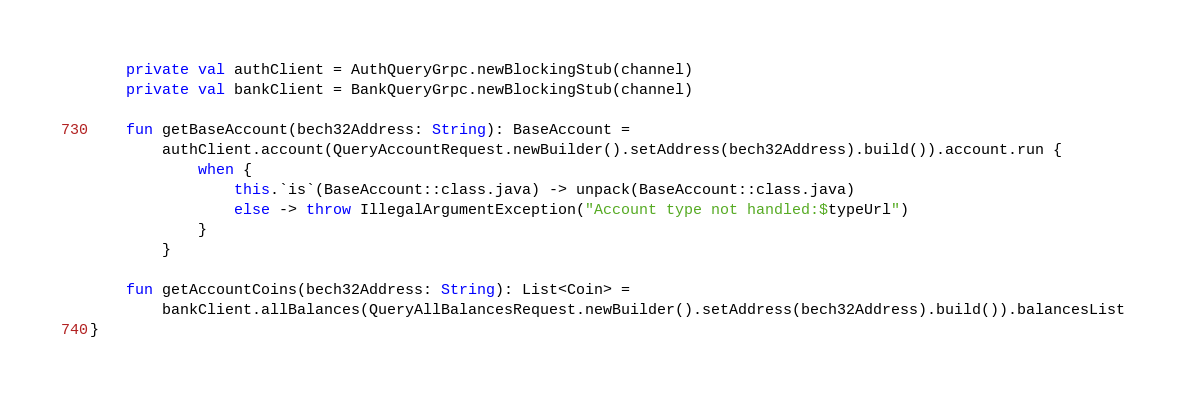<code> <loc_0><loc_0><loc_500><loc_500><_Kotlin_>
    private val authClient = AuthQueryGrpc.newBlockingStub(channel)
    private val bankClient = BankQueryGrpc.newBlockingStub(channel)

    fun getBaseAccount(bech32Address: String): BaseAccount =
        authClient.account(QueryAccountRequest.newBuilder().setAddress(bech32Address).build()).account.run {
            when {
                this.`is`(BaseAccount::class.java) -> unpack(BaseAccount::class.java)
                else -> throw IllegalArgumentException("Account type not handled:$typeUrl")
            }
        }

    fun getAccountCoins(bech32Address: String): List<Coin> =
        bankClient.allBalances(QueryAllBalancesRequest.newBuilder().setAddress(bech32Address).build()).balancesList
}
</code> 